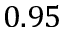Convert formula to latex. <formula><loc_0><loc_0><loc_500><loc_500>0 . 9 5</formula> 